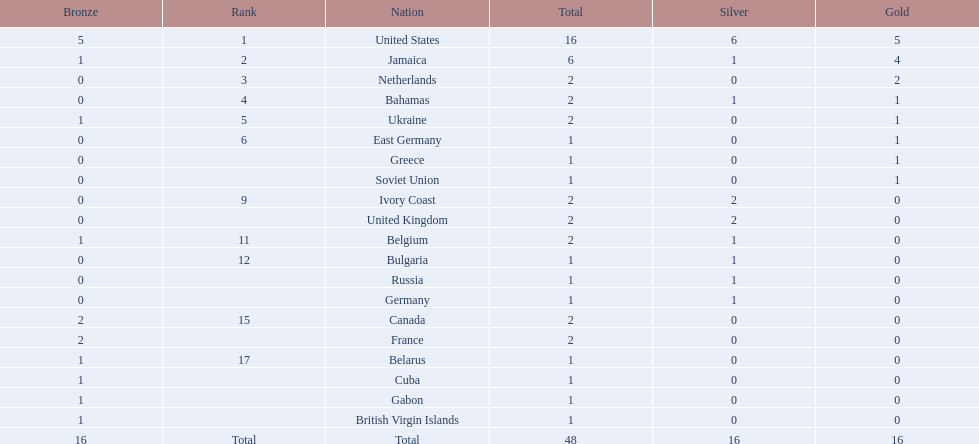How many nations won at least two gold medals? 3. 